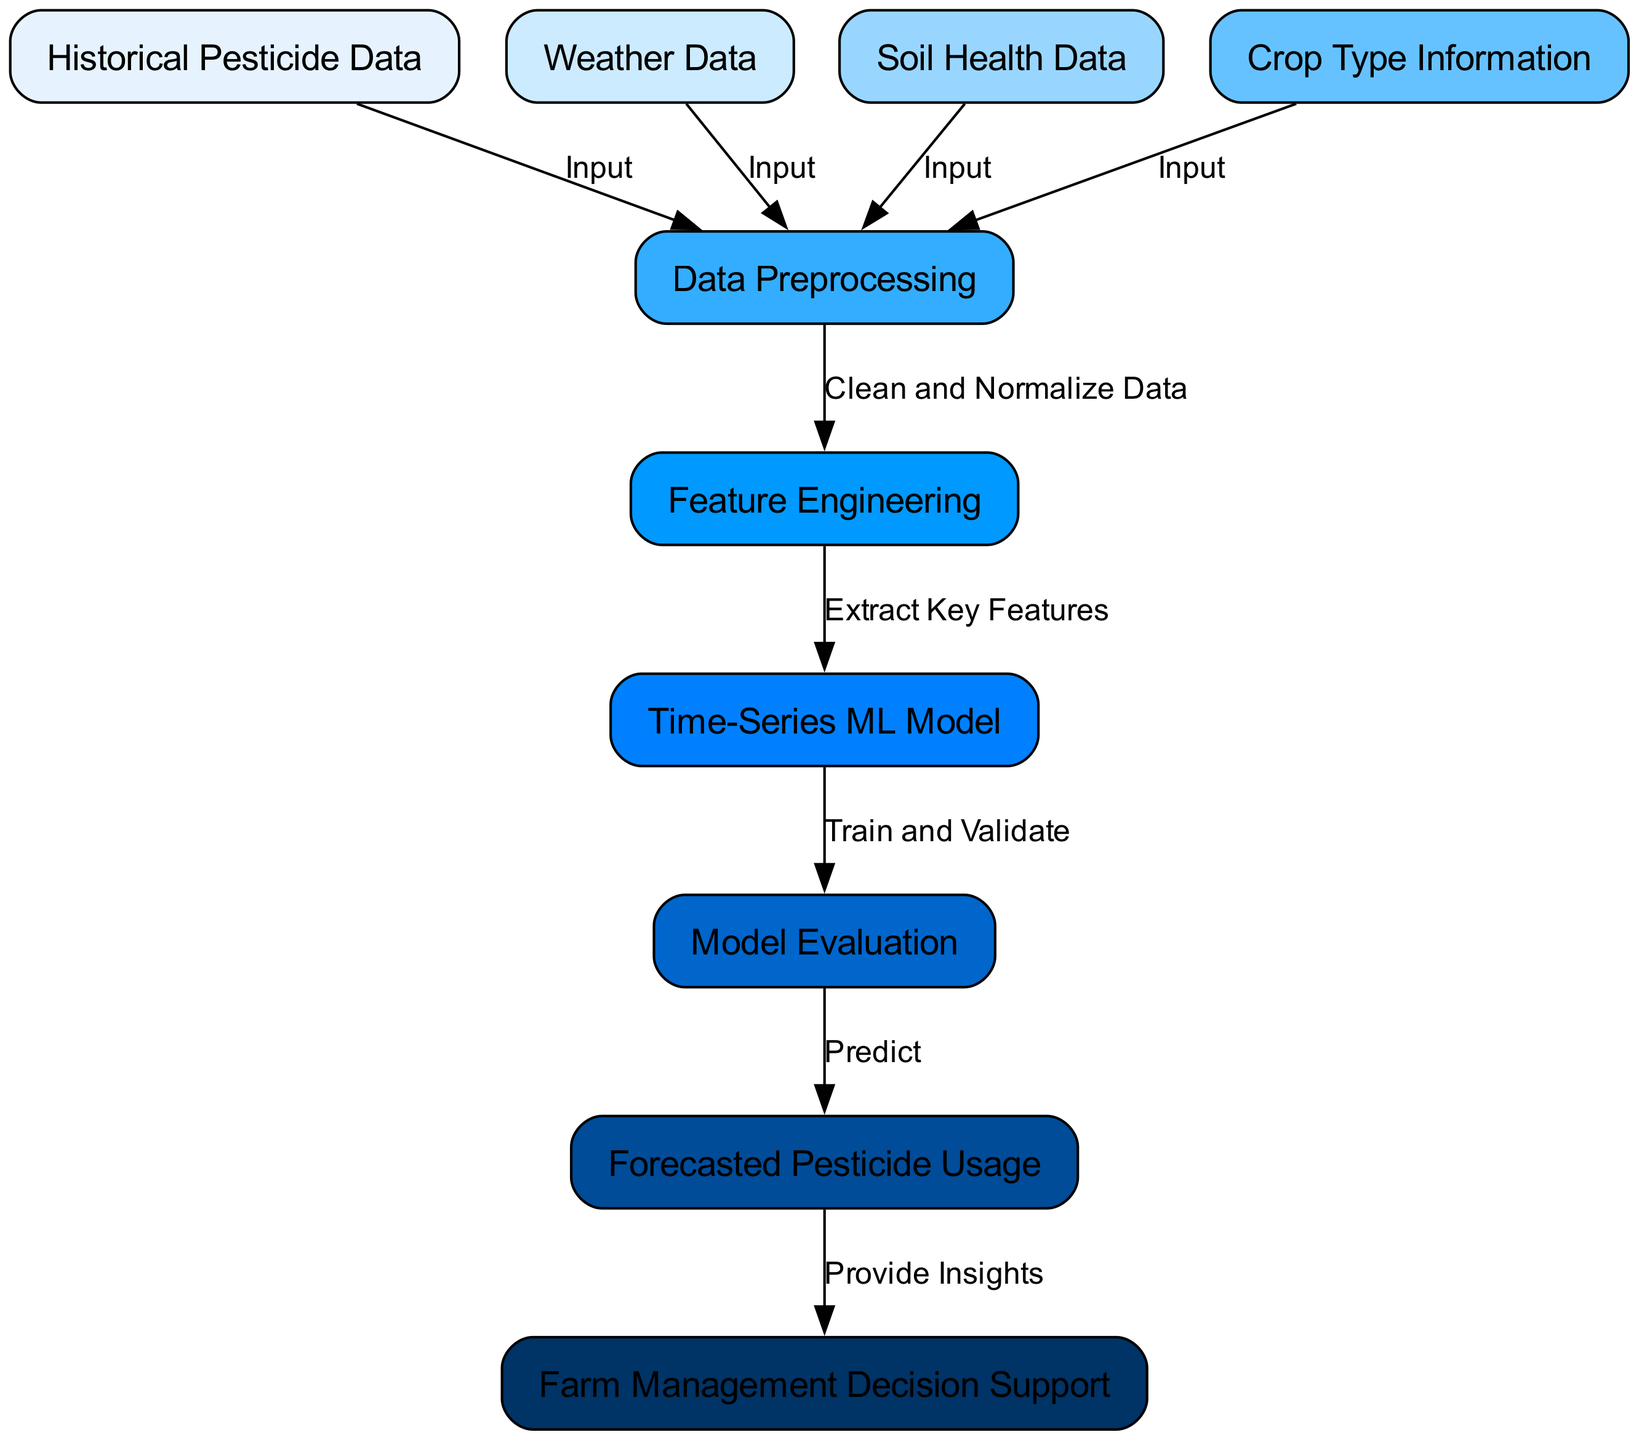What is the total number of nodes in the diagram? The diagram contains a total of 10 distinct nodes representing various stages and data points in the forecasting process.
Answer: 10 Which node represents the process of cleaning and normalizing data? The diagram shows a directional flow from the "Data Preprocessing" node to the "Feature Engineering" node, indicating that "Data Preprocessing" includes cleaning and normalizing data.
Answer: Data Preprocessing What type of model is used for forecasting pesticide usage? The flow indicates that the "Time-Series ML Model" is specifically designed for making predictions about pesticide usage based on historical data and other inputs.
Answer: Time-Series ML Model How many inputs are there for the "Data Preprocessing" node? The "Data Preprocessing" node receives input from four different nodes: Historical Pesticide Data, Weather Data, Soil Health Data, and Crop Type Information, thus totaling four inputs.
Answer: 4 What is the output of the "Model Evaluation" node? The "Model Evaluation" node directs its output to the "Forecasted Pesticide Usage" node, signifying that its purpose is to assess the model's performance before making predictions.
Answer: Forecasted Pesticide Usage What is the final step in the diagram following the "Forecasted Pesticide Usage"? The flow diagram indicates that after forecasting pesticide usage, the process leads to "Farm Management Decision Support," which means this is the final step in the sequence.
Answer: Farm Management Decision Support Which type of data is NOT included in the inputs to the "Data Preprocessing" node? The "Data Preprocessing" node requires data from Historical Pesticide Data, Weather Data, Soil Health Data, and Crop Type Information; therefore, any data type not listed here does not serve as its input. For instance, environmental data is not included.
Answer: Environmental Data What is the function of the "Feature Engineering" node? "Feature Engineering" processes the cleaned data into key features necessary for the Time-Series ML Model, aiding in enhancing the model's predictive performance based on relevant inputs.
Answer: Extract Key Features Which node directly follows the "Train and Validate" stage? The progression shows that "Model Evaluation" directly follows "Train and Validate," highlighting the importance of evaluating the model's performance after training and validation processes.
Answer: Model Evaluation 